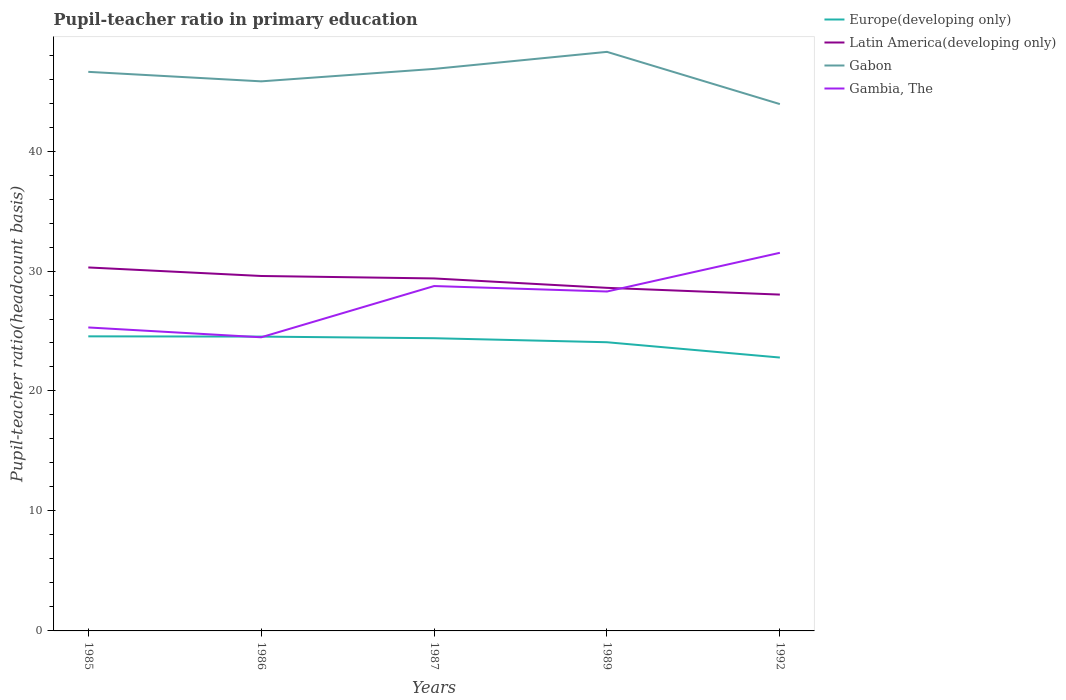Does the line corresponding to Gabon intersect with the line corresponding to Gambia, The?
Your answer should be very brief. No. Across all years, what is the maximum pupil-teacher ratio in primary education in Latin America(developing only)?
Provide a short and direct response. 28.03. In which year was the pupil-teacher ratio in primary education in Latin America(developing only) maximum?
Keep it short and to the point. 1992. What is the total pupil-teacher ratio in primary education in Europe(developing only) in the graph?
Offer a very short reply. 1.28. What is the difference between the highest and the second highest pupil-teacher ratio in primary education in Europe(developing only)?
Offer a very short reply. 1.77. What is the difference between the highest and the lowest pupil-teacher ratio in primary education in Gambia, The?
Offer a very short reply. 3. Is the pupil-teacher ratio in primary education in Gabon strictly greater than the pupil-teacher ratio in primary education in Latin America(developing only) over the years?
Ensure brevity in your answer.  No. How many lines are there?
Provide a short and direct response. 4. What is the title of the graph?
Keep it short and to the point. Pupil-teacher ratio in primary education. Does "Israel" appear as one of the legend labels in the graph?
Your answer should be compact. No. What is the label or title of the Y-axis?
Keep it short and to the point. Pupil-teacher ratio(headcount basis). What is the Pupil-teacher ratio(headcount basis) in Europe(developing only) in 1985?
Provide a short and direct response. 24.55. What is the Pupil-teacher ratio(headcount basis) in Latin America(developing only) in 1985?
Give a very brief answer. 30.3. What is the Pupil-teacher ratio(headcount basis) of Gabon in 1985?
Keep it short and to the point. 46.6. What is the Pupil-teacher ratio(headcount basis) in Gambia, The in 1985?
Make the answer very short. 25.3. What is the Pupil-teacher ratio(headcount basis) of Europe(developing only) in 1986?
Provide a succinct answer. 24.53. What is the Pupil-teacher ratio(headcount basis) of Latin America(developing only) in 1986?
Make the answer very short. 29.59. What is the Pupil-teacher ratio(headcount basis) of Gabon in 1986?
Offer a very short reply. 45.81. What is the Pupil-teacher ratio(headcount basis) of Gambia, The in 1986?
Your answer should be very brief. 24.48. What is the Pupil-teacher ratio(headcount basis) of Europe(developing only) in 1987?
Offer a very short reply. 24.4. What is the Pupil-teacher ratio(headcount basis) of Latin America(developing only) in 1987?
Offer a terse response. 29.38. What is the Pupil-teacher ratio(headcount basis) of Gabon in 1987?
Give a very brief answer. 46.85. What is the Pupil-teacher ratio(headcount basis) in Gambia, The in 1987?
Your answer should be very brief. 28.75. What is the Pupil-teacher ratio(headcount basis) of Europe(developing only) in 1989?
Offer a terse response. 24.06. What is the Pupil-teacher ratio(headcount basis) in Latin America(developing only) in 1989?
Give a very brief answer. 28.6. What is the Pupil-teacher ratio(headcount basis) of Gabon in 1989?
Offer a terse response. 48.27. What is the Pupil-teacher ratio(headcount basis) in Gambia, The in 1989?
Keep it short and to the point. 28.29. What is the Pupil-teacher ratio(headcount basis) in Europe(developing only) in 1992?
Your response must be concise. 22.79. What is the Pupil-teacher ratio(headcount basis) in Latin America(developing only) in 1992?
Offer a terse response. 28.03. What is the Pupil-teacher ratio(headcount basis) in Gabon in 1992?
Make the answer very short. 43.91. What is the Pupil-teacher ratio(headcount basis) of Gambia, The in 1992?
Give a very brief answer. 31.52. Across all years, what is the maximum Pupil-teacher ratio(headcount basis) in Europe(developing only)?
Keep it short and to the point. 24.55. Across all years, what is the maximum Pupil-teacher ratio(headcount basis) of Latin America(developing only)?
Keep it short and to the point. 30.3. Across all years, what is the maximum Pupil-teacher ratio(headcount basis) in Gabon?
Provide a short and direct response. 48.27. Across all years, what is the maximum Pupil-teacher ratio(headcount basis) of Gambia, The?
Offer a terse response. 31.52. Across all years, what is the minimum Pupil-teacher ratio(headcount basis) in Europe(developing only)?
Provide a succinct answer. 22.79. Across all years, what is the minimum Pupil-teacher ratio(headcount basis) in Latin America(developing only)?
Make the answer very short. 28.03. Across all years, what is the minimum Pupil-teacher ratio(headcount basis) in Gabon?
Give a very brief answer. 43.91. Across all years, what is the minimum Pupil-teacher ratio(headcount basis) in Gambia, The?
Your answer should be compact. 24.48. What is the total Pupil-teacher ratio(headcount basis) in Europe(developing only) in the graph?
Provide a short and direct response. 120.34. What is the total Pupil-teacher ratio(headcount basis) in Latin America(developing only) in the graph?
Your response must be concise. 145.9. What is the total Pupil-teacher ratio(headcount basis) in Gabon in the graph?
Provide a succinct answer. 231.44. What is the total Pupil-teacher ratio(headcount basis) of Gambia, The in the graph?
Your answer should be compact. 138.33. What is the difference between the Pupil-teacher ratio(headcount basis) of Europe(developing only) in 1985 and that in 1986?
Provide a short and direct response. 0.02. What is the difference between the Pupil-teacher ratio(headcount basis) of Latin America(developing only) in 1985 and that in 1986?
Give a very brief answer. 0.71. What is the difference between the Pupil-teacher ratio(headcount basis) of Gabon in 1985 and that in 1986?
Ensure brevity in your answer.  0.79. What is the difference between the Pupil-teacher ratio(headcount basis) of Gambia, The in 1985 and that in 1986?
Offer a very short reply. 0.82. What is the difference between the Pupil-teacher ratio(headcount basis) of Europe(developing only) in 1985 and that in 1987?
Your answer should be very brief. 0.16. What is the difference between the Pupil-teacher ratio(headcount basis) of Latin America(developing only) in 1985 and that in 1987?
Offer a terse response. 0.92. What is the difference between the Pupil-teacher ratio(headcount basis) in Gabon in 1985 and that in 1987?
Your answer should be compact. -0.25. What is the difference between the Pupil-teacher ratio(headcount basis) in Gambia, The in 1985 and that in 1987?
Your answer should be compact. -3.45. What is the difference between the Pupil-teacher ratio(headcount basis) in Europe(developing only) in 1985 and that in 1989?
Give a very brief answer. 0.49. What is the difference between the Pupil-teacher ratio(headcount basis) in Latin America(developing only) in 1985 and that in 1989?
Ensure brevity in your answer.  1.7. What is the difference between the Pupil-teacher ratio(headcount basis) in Gabon in 1985 and that in 1989?
Ensure brevity in your answer.  -1.67. What is the difference between the Pupil-teacher ratio(headcount basis) of Gambia, The in 1985 and that in 1989?
Give a very brief answer. -3. What is the difference between the Pupil-teacher ratio(headcount basis) of Europe(developing only) in 1985 and that in 1992?
Give a very brief answer. 1.77. What is the difference between the Pupil-teacher ratio(headcount basis) in Latin America(developing only) in 1985 and that in 1992?
Make the answer very short. 2.26. What is the difference between the Pupil-teacher ratio(headcount basis) of Gabon in 1985 and that in 1992?
Your answer should be compact. 2.69. What is the difference between the Pupil-teacher ratio(headcount basis) of Gambia, The in 1985 and that in 1992?
Your response must be concise. -6.22. What is the difference between the Pupil-teacher ratio(headcount basis) in Europe(developing only) in 1986 and that in 1987?
Make the answer very short. 0.14. What is the difference between the Pupil-teacher ratio(headcount basis) in Latin America(developing only) in 1986 and that in 1987?
Make the answer very short. 0.2. What is the difference between the Pupil-teacher ratio(headcount basis) of Gabon in 1986 and that in 1987?
Keep it short and to the point. -1.04. What is the difference between the Pupil-teacher ratio(headcount basis) of Gambia, The in 1986 and that in 1987?
Provide a short and direct response. -4.27. What is the difference between the Pupil-teacher ratio(headcount basis) of Europe(developing only) in 1986 and that in 1989?
Give a very brief answer. 0.47. What is the difference between the Pupil-teacher ratio(headcount basis) in Latin America(developing only) in 1986 and that in 1989?
Keep it short and to the point. 0.99. What is the difference between the Pupil-teacher ratio(headcount basis) in Gabon in 1986 and that in 1989?
Offer a terse response. -2.46. What is the difference between the Pupil-teacher ratio(headcount basis) of Gambia, The in 1986 and that in 1989?
Keep it short and to the point. -3.82. What is the difference between the Pupil-teacher ratio(headcount basis) of Europe(developing only) in 1986 and that in 1992?
Keep it short and to the point. 1.75. What is the difference between the Pupil-teacher ratio(headcount basis) of Latin America(developing only) in 1986 and that in 1992?
Give a very brief answer. 1.55. What is the difference between the Pupil-teacher ratio(headcount basis) of Gabon in 1986 and that in 1992?
Give a very brief answer. 1.9. What is the difference between the Pupil-teacher ratio(headcount basis) in Gambia, The in 1986 and that in 1992?
Your response must be concise. -7.04. What is the difference between the Pupil-teacher ratio(headcount basis) in Europe(developing only) in 1987 and that in 1989?
Your answer should be very brief. 0.34. What is the difference between the Pupil-teacher ratio(headcount basis) in Latin America(developing only) in 1987 and that in 1989?
Make the answer very short. 0.78. What is the difference between the Pupil-teacher ratio(headcount basis) of Gabon in 1987 and that in 1989?
Offer a very short reply. -1.42. What is the difference between the Pupil-teacher ratio(headcount basis) of Gambia, The in 1987 and that in 1989?
Ensure brevity in your answer.  0.45. What is the difference between the Pupil-teacher ratio(headcount basis) in Europe(developing only) in 1987 and that in 1992?
Ensure brevity in your answer.  1.61. What is the difference between the Pupil-teacher ratio(headcount basis) in Latin America(developing only) in 1987 and that in 1992?
Provide a succinct answer. 1.35. What is the difference between the Pupil-teacher ratio(headcount basis) in Gabon in 1987 and that in 1992?
Ensure brevity in your answer.  2.93. What is the difference between the Pupil-teacher ratio(headcount basis) in Gambia, The in 1987 and that in 1992?
Make the answer very short. -2.77. What is the difference between the Pupil-teacher ratio(headcount basis) of Europe(developing only) in 1989 and that in 1992?
Your response must be concise. 1.27. What is the difference between the Pupil-teacher ratio(headcount basis) of Latin America(developing only) in 1989 and that in 1992?
Your response must be concise. 0.56. What is the difference between the Pupil-teacher ratio(headcount basis) of Gabon in 1989 and that in 1992?
Make the answer very short. 4.35. What is the difference between the Pupil-teacher ratio(headcount basis) in Gambia, The in 1989 and that in 1992?
Your answer should be compact. -3.23. What is the difference between the Pupil-teacher ratio(headcount basis) of Europe(developing only) in 1985 and the Pupil-teacher ratio(headcount basis) of Latin America(developing only) in 1986?
Keep it short and to the point. -5.03. What is the difference between the Pupil-teacher ratio(headcount basis) of Europe(developing only) in 1985 and the Pupil-teacher ratio(headcount basis) of Gabon in 1986?
Make the answer very short. -21.26. What is the difference between the Pupil-teacher ratio(headcount basis) of Europe(developing only) in 1985 and the Pupil-teacher ratio(headcount basis) of Gambia, The in 1986?
Your answer should be compact. 0.08. What is the difference between the Pupil-teacher ratio(headcount basis) in Latin America(developing only) in 1985 and the Pupil-teacher ratio(headcount basis) in Gabon in 1986?
Your response must be concise. -15.51. What is the difference between the Pupil-teacher ratio(headcount basis) in Latin America(developing only) in 1985 and the Pupil-teacher ratio(headcount basis) in Gambia, The in 1986?
Give a very brief answer. 5.82. What is the difference between the Pupil-teacher ratio(headcount basis) of Gabon in 1985 and the Pupil-teacher ratio(headcount basis) of Gambia, The in 1986?
Offer a terse response. 22.13. What is the difference between the Pupil-teacher ratio(headcount basis) in Europe(developing only) in 1985 and the Pupil-teacher ratio(headcount basis) in Latin America(developing only) in 1987?
Keep it short and to the point. -4.83. What is the difference between the Pupil-teacher ratio(headcount basis) of Europe(developing only) in 1985 and the Pupil-teacher ratio(headcount basis) of Gabon in 1987?
Your answer should be compact. -22.29. What is the difference between the Pupil-teacher ratio(headcount basis) in Europe(developing only) in 1985 and the Pupil-teacher ratio(headcount basis) in Gambia, The in 1987?
Offer a very short reply. -4.19. What is the difference between the Pupil-teacher ratio(headcount basis) of Latin America(developing only) in 1985 and the Pupil-teacher ratio(headcount basis) of Gabon in 1987?
Give a very brief answer. -16.55. What is the difference between the Pupil-teacher ratio(headcount basis) of Latin America(developing only) in 1985 and the Pupil-teacher ratio(headcount basis) of Gambia, The in 1987?
Your response must be concise. 1.55. What is the difference between the Pupil-teacher ratio(headcount basis) in Gabon in 1985 and the Pupil-teacher ratio(headcount basis) in Gambia, The in 1987?
Ensure brevity in your answer.  17.86. What is the difference between the Pupil-teacher ratio(headcount basis) in Europe(developing only) in 1985 and the Pupil-teacher ratio(headcount basis) in Latin America(developing only) in 1989?
Ensure brevity in your answer.  -4.04. What is the difference between the Pupil-teacher ratio(headcount basis) in Europe(developing only) in 1985 and the Pupil-teacher ratio(headcount basis) in Gabon in 1989?
Ensure brevity in your answer.  -23.71. What is the difference between the Pupil-teacher ratio(headcount basis) in Europe(developing only) in 1985 and the Pupil-teacher ratio(headcount basis) in Gambia, The in 1989?
Give a very brief answer. -3.74. What is the difference between the Pupil-teacher ratio(headcount basis) in Latin America(developing only) in 1985 and the Pupil-teacher ratio(headcount basis) in Gabon in 1989?
Offer a terse response. -17.97. What is the difference between the Pupil-teacher ratio(headcount basis) of Latin America(developing only) in 1985 and the Pupil-teacher ratio(headcount basis) of Gambia, The in 1989?
Provide a short and direct response. 2.01. What is the difference between the Pupil-teacher ratio(headcount basis) of Gabon in 1985 and the Pupil-teacher ratio(headcount basis) of Gambia, The in 1989?
Offer a very short reply. 18.31. What is the difference between the Pupil-teacher ratio(headcount basis) in Europe(developing only) in 1985 and the Pupil-teacher ratio(headcount basis) in Latin America(developing only) in 1992?
Give a very brief answer. -3.48. What is the difference between the Pupil-teacher ratio(headcount basis) of Europe(developing only) in 1985 and the Pupil-teacher ratio(headcount basis) of Gabon in 1992?
Ensure brevity in your answer.  -19.36. What is the difference between the Pupil-teacher ratio(headcount basis) of Europe(developing only) in 1985 and the Pupil-teacher ratio(headcount basis) of Gambia, The in 1992?
Ensure brevity in your answer.  -6.96. What is the difference between the Pupil-teacher ratio(headcount basis) of Latin America(developing only) in 1985 and the Pupil-teacher ratio(headcount basis) of Gabon in 1992?
Give a very brief answer. -13.62. What is the difference between the Pupil-teacher ratio(headcount basis) in Latin America(developing only) in 1985 and the Pupil-teacher ratio(headcount basis) in Gambia, The in 1992?
Give a very brief answer. -1.22. What is the difference between the Pupil-teacher ratio(headcount basis) in Gabon in 1985 and the Pupil-teacher ratio(headcount basis) in Gambia, The in 1992?
Offer a very short reply. 15.08. What is the difference between the Pupil-teacher ratio(headcount basis) of Europe(developing only) in 1986 and the Pupil-teacher ratio(headcount basis) of Latin America(developing only) in 1987?
Give a very brief answer. -4.85. What is the difference between the Pupil-teacher ratio(headcount basis) of Europe(developing only) in 1986 and the Pupil-teacher ratio(headcount basis) of Gabon in 1987?
Give a very brief answer. -22.31. What is the difference between the Pupil-teacher ratio(headcount basis) of Europe(developing only) in 1986 and the Pupil-teacher ratio(headcount basis) of Gambia, The in 1987?
Provide a short and direct response. -4.21. What is the difference between the Pupil-teacher ratio(headcount basis) of Latin America(developing only) in 1986 and the Pupil-teacher ratio(headcount basis) of Gabon in 1987?
Offer a terse response. -17.26. What is the difference between the Pupil-teacher ratio(headcount basis) in Latin America(developing only) in 1986 and the Pupil-teacher ratio(headcount basis) in Gambia, The in 1987?
Your answer should be very brief. 0.84. What is the difference between the Pupil-teacher ratio(headcount basis) in Gabon in 1986 and the Pupil-teacher ratio(headcount basis) in Gambia, The in 1987?
Ensure brevity in your answer.  17.06. What is the difference between the Pupil-teacher ratio(headcount basis) of Europe(developing only) in 1986 and the Pupil-teacher ratio(headcount basis) of Latin America(developing only) in 1989?
Your response must be concise. -4.06. What is the difference between the Pupil-teacher ratio(headcount basis) of Europe(developing only) in 1986 and the Pupil-teacher ratio(headcount basis) of Gabon in 1989?
Offer a very short reply. -23.73. What is the difference between the Pupil-teacher ratio(headcount basis) of Europe(developing only) in 1986 and the Pupil-teacher ratio(headcount basis) of Gambia, The in 1989?
Provide a succinct answer. -3.76. What is the difference between the Pupil-teacher ratio(headcount basis) of Latin America(developing only) in 1986 and the Pupil-teacher ratio(headcount basis) of Gabon in 1989?
Offer a very short reply. -18.68. What is the difference between the Pupil-teacher ratio(headcount basis) of Latin America(developing only) in 1986 and the Pupil-teacher ratio(headcount basis) of Gambia, The in 1989?
Make the answer very short. 1.29. What is the difference between the Pupil-teacher ratio(headcount basis) of Gabon in 1986 and the Pupil-teacher ratio(headcount basis) of Gambia, The in 1989?
Provide a succinct answer. 17.52. What is the difference between the Pupil-teacher ratio(headcount basis) of Europe(developing only) in 1986 and the Pupil-teacher ratio(headcount basis) of Latin America(developing only) in 1992?
Offer a terse response. -3.5. What is the difference between the Pupil-teacher ratio(headcount basis) in Europe(developing only) in 1986 and the Pupil-teacher ratio(headcount basis) in Gabon in 1992?
Offer a very short reply. -19.38. What is the difference between the Pupil-teacher ratio(headcount basis) in Europe(developing only) in 1986 and the Pupil-teacher ratio(headcount basis) in Gambia, The in 1992?
Ensure brevity in your answer.  -6.98. What is the difference between the Pupil-teacher ratio(headcount basis) of Latin America(developing only) in 1986 and the Pupil-teacher ratio(headcount basis) of Gabon in 1992?
Provide a succinct answer. -14.33. What is the difference between the Pupil-teacher ratio(headcount basis) in Latin America(developing only) in 1986 and the Pupil-teacher ratio(headcount basis) in Gambia, The in 1992?
Make the answer very short. -1.93. What is the difference between the Pupil-teacher ratio(headcount basis) of Gabon in 1986 and the Pupil-teacher ratio(headcount basis) of Gambia, The in 1992?
Provide a short and direct response. 14.29. What is the difference between the Pupil-teacher ratio(headcount basis) in Europe(developing only) in 1987 and the Pupil-teacher ratio(headcount basis) in Latin America(developing only) in 1989?
Keep it short and to the point. -4.2. What is the difference between the Pupil-teacher ratio(headcount basis) of Europe(developing only) in 1987 and the Pupil-teacher ratio(headcount basis) of Gabon in 1989?
Provide a succinct answer. -23.87. What is the difference between the Pupil-teacher ratio(headcount basis) in Europe(developing only) in 1987 and the Pupil-teacher ratio(headcount basis) in Gambia, The in 1989?
Your answer should be very brief. -3.89. What is the difference between the Pupil-teacher ratio(headcount basis) in Latin America(developing only) in 1987 and the Pupil-teacher ratio(headcount basis) in Gabon in 1989?
Your response must be concise. -18.89. What is the difference between the Pupil-teacher ratio(headcount basis) in Latin America(developing only) in 1987 and the Pupil-teacher ratio(headcount basis) in Gambia, The in 1989?
Provide a short and direct response. 1.09. What is the difference between the Pupil-teacher ratio(headcount basis) in Gabon in 1987 and the Pupil-teacher ratio(headcount basis) in Gambia, The in 1989?
Ensure brevity in your answer.  18.56. What is the difference between the Pupil-teacher ratio(headcount basis) in Europe(developing only) in 1987 and the Pupil-teacher ratio(headcount basis) in Latin America(developing only) in 1992?
Your answer should be compact. -3.64. What is the difference between the Pupil-teacher ratio(headcount basis) of Europe(developing only) in 1987 and the Pupil-teacher ratio(headcount basis) of Gabon in 1992?
Provide a succinct answer. -19.52. What is the difference between the Pupil-teacher ratio(headcount basis) of Europe(developing only) in 1987 and the Pupil-teacher ratio(headcount basis) of Gambia, The in 1992?
Offer a very short reply. -7.12. What is the difference between the Pupil-teacher ratio(headcount basis) of Latin America(developing only) in 1987 and the Pupil-teacher ratio(headcount basis) of Gabon in 1992?
Your response must be concise. -14.53. What is the difference between the Pupil-teacher ratio(headcount basis) in Latin America(developing only) in 1987 and the Pupil-teacher ratio(headcount basis) in Gambia, The in 1992?
Ensure brevity in your answer.  -2.14. What is the difference between the Pupil-teacher ratio(headcount basis) of Gabon in 1987 and the Pupil-teacher ratio(headcount basis) of Gambia, The in 1992?
Give a very brief answer. 15.33. What is the difference between the Pupil-teacher ratio(headcount basis) of Europe(developing only) in 1989 and the Pupil-teacher ratio(headcount basis) of Latin America(developing only) in 1992?
Your answer should be very brief. -3.97. What is the difference between the Pupil-teacher ratio(headcount basis) in Europe(developing only) in 1989 and the Pupil-teacher ratio(headcount basis) in Gabon in 1992?
Give a very brief answer. -19.85. What is the difference between the Pupil-teacher ratio(headcount basis) of Europe(developing only) in 1989 and the Pupil-teacher ratio(headcount basis) of Gambia, The in 1992?
Offer a terse response. -7.45. What is the difference between the Pupil-teacher ratio(headcount basis) in Latin America(developing only) in 1989 and the Pupil-teacher ratio(headcount basis) in Gabon in 1992?
Provide a short and direct response. -15.32. What is the difference between the Pupil-teacher ratio(headcount basis) in Latin America(developing only) in 1989 and the Pupil-teacher ratio(headcount basis) in Gambia, The in 1992?
Make the answer very short. -2.92. What is the difference between the Pupil-teacher ratio(headcount basis) of Gabon in 1989 and the Pupil-teacher ratio(headcount basis) of Gambia, The in 1992?
Offer a very short reply. 16.75. What is the average Pupil-teacher ratio(headcount basis) of Europe(developing only) per year?
Make the answer very short. 24.07. What is the average Pupil-teacher ratio(headcount basis) in Latin America(developing only) per year?
Give a very brief answer. 29.18. What is the average Pupil-teacher ratio(headcount basis) in Gabon per year?
Ensure brevity in your answer.  46.29. What is the average Pupil-teacher ratio(headcount basis) of Gambia, The per year?
Your answer should be compact. 27.67. In the year 1985, what is the difference between the Pupil-teacher ratio(headcount basis) in Europe(developing only) and Pupil-teacher ratio(headcount basis) in Latin America(developing only)?
Your response must be concise. -5.74. In the year 1985, what is the difference between the Pupil-teacher ratio(headcount basis) of Europe(developing only) and Pupil-teacher ratio(headcount basis) of Gabon?
Your response must be concise. -22.05. In the year 1985, what is the difference between the Pupil-teacher ratio(headcount basis) in Europe(developing only) and Pupil-teacher ratio(headcount basis) in Gambia, The?
Your answer should be compact. -0.74. In the year 1985, what is the difference between the Pupil-teacher ratio(headcount basis) of Latin America(developing only) and Pupil-teacher ratio(headcount basis) of Gabon?
Your answer should be very brief. -16.3. In the year 1985, what is the difference between the Pupil-teacher ratio(headcount basis) of Latin America(developing only) and Pupil-teacher ratio(headcount basis) of Gambia, The?
Your answer should be compact. 5. In the year 1985, what is the difference between the Pupil-teacher ratio(headcount basis) in Gabon and Pupil-teacher ratio(headcount basis) in Gambia, The?
Provide a short and direct response. 21.31. In the year 1986, what is the difference between the Pupil-teacher ratio(headcount basis) of Europe(developing only) and Pupil-teacher ratio(headcount basis) of Latin America(developing only)?
Offer a very short reply. -5.05. In the year 1986, what is the difference between the Pupil-teacher ratio(headcount basis) in Europe(developing only) and Pupil-teacher ratio(headcount basis) in Gabon?
Offer a terse response. -21.28. In the year 1986, what is the difference between the Pupil-teacher ratio(headcount basis) of Europe(developing only) and Pupil-teacher ratio(headcount basis) of Gambia, The?
Provide a succinct answer. 0.06. In the year 1986, what is the difference between the Pupil-teacher ratio(headcount basis) of Latin America(developing only) and Pupil-teacher ratio(headcount basis) of Gabon?
Make the answer very short. -16.22. In the year 1986, what is the difference between the Pupil-teacher ratio(headcount basis) of Latin America(developing only) and Pupil-teacher ratio(headcount basis) of Gambia, The?
Your answer should be very brief. 5.11. In the year 1986, what is the difference between the Pupil-teacher ratio(headcount basis) in Gabon and Pupil-teacher ratio(headcount basis) in Gambia, The?
Provide a short and direct response. 21.33. In the year 1987, what is the difference between the Pupil-teacher ratio(headcount basis) in Europe(developing only) and Pupil-teacher ratio(headcount basis) in Latin America(developing only)?
Your response must be concise. -4.98. In the year 1987, what is the difference between the Pupil-teacher ratio(headcount basis) in Europe(developing only) and Pupil-teacher ratio(headcount basis) in Gabon?
Your answer should be very brief. -22.45. In the year 1987, what is the difference between the Pupil-teacher ratio(headcount basis) in Europe(developing only) and Pupil-teacher ratio(headcount basis) in Gambia, The?
Make the answer very short. -4.35. In the year 1987, what is the difference between the Pupil-teacher ratio(headcount basis) of Latin America(developing only) and Pupil-teacher ratio(headcount basis) of Gabon?
Make the answer very short. -17.47. In the year 1987, what is the difference between the Pupil-teacher ratio(headcount basis) in Latin America(developing only) and Pupil-teacher ratio(headcount basis) in Gambia, The?
Offer a terse response. 0.63. In the year 1987, what is the difference between the Pupil-teacher ratio(headcount basis) of Gabon and Pupil-teacher ratio(headcount basis) of Gambia, The?
Provide a succinct answer. 18.1. In the year 1989, what is the difference between the Pupil-teacher ratio(headcount basis) in Europe(developing only) and Pupil-teacher ratio(headcount basis) in Latin America(developing only)?
Keep it short and to the point. -4.53. In the year 1989, what is the difference between the Pupil-teacher ratio(headcount basis) in Europe(developing only) and Pupil-teacher ratio(headcount basis) in Gabon?
Offer a very short reply. -24.21. In the year 1989, what is the difference between the Pupil-teacher ratio(headcount basis) in Europe(developing only) and Pupil-teacher ratio(headcount basis) in Gambia, The?
Offer a very short reply. -4.23. In the year 1989, what is the difference between the Pupil-teacher ratio(headcount basis) of Latin America(developing only) and Pupil-teacher ratio(headcount basis) of Gabon?
Your answer should be compact. -19.67. In the year 1989, what is the difference between the Pupil-teacher ratio(headcount basis) of Latin America(developing only) and Pupil-teacher ratio(headcount basis) of Gambia, The?
Your response must be concise. 0.3. In the year 1989, what is the difference between the Pupil-teacher ratio(headcount basis) in Gabon and Pupil-teacher ratio(headcount basis) in Gambia, The?
Make the answer very short. 19.98. In the year 1992, what is the difference between the Pupil-teacher ratio(headcount basis) in Europe(developing only) and Pupil-teacher ratio(headcount basis) in Latin America(developing only)?
Your response must be concise. -5.25. In the year 1992, what is the difference between the Pupil-teacher ratio(headcount basis) of Europe(developing only) and Pupil-teacher ratio(headcount basis) of Gabon?
Make the answer very short. -21.13. In the year 1992, what is the difference between the Pupil-teacher ratio(headcount basis) of Europe(developing only) and Pupil-teacher ratio(headcount basis) of Gambia, The?
Offer a very short reply. -8.73. In the year 1992, what is the difference between the Pupil-teacher ratio(headcount basis) of Latin America(developing only) and Pupil-teacher ratio(headcount basis) of Gabon?
Provide a succinct answer. -15.88. In the year 1992, what is the difference between the Pupil-teacher ratio(headcount basis) in Latin America(developing only) and Pupil-teacher ratio(headcount basis) in Gambia, The?
Provide a succinct answer. -3.48. In the year 1992, what is the difference between the Pupil-teacher ratio(headcount basis) of Gabon and Pupil-teacher ratio(headcount basis) of Gambia, The?
Your answer should be very brief. 12.4. What is the ratio of the Pupil-teacher ratio(headcount basis) in Latin America(developing only) in 1985 to that in 1986?
Keep it short and to the point. 1.02. What is the ratio of the Pupil-teacher ratio(headcount basis) of Gabon in 1985 to that in 1986?
Provide a succinct answer. 1.02. What is the ratio of the Pupil-teacher ratio(headcount basis) in Gambia, The in 1985 to that in 1986?
Your response must be concise. 1.03. What is the ratio of the Pupil-teacher ratio(headcount basis) in Europe(developing only) in 1985 to that in 1987?
Offer a terse response. 1.01. What is the ratio of the Pupil-teacher ratio(headcount basis) in Latin America(developing only) in 1985 to that in 1987?
Provide a short and direct response. 1.03. What is the ratio of the Pupil-teacher ratio(headcount basis) of Gambia, The in 1985 to that in 1987?
Your response must be concise. 0.88. What is the ratio of the Pupil-teacher ratio(headcount basis) of Europe(developing only) in 1985 to that in 1989?
Your response must be concise. 1.02. What is the ratio of the Pupil-teacher ratio(headcount basis) in Latin America(developing only) in 1985 to that in 1989?
Provide a succinct answer. 1.06. What is the ratio of the Pupil-teacher ratio(headcount basis) in Gabon in 1985 to that in 1989?
Give a very brief answer. 0.97. What is the ratio of the Pupil-teacher ratio(headcount basis) in Gambia, The in 1985 to that in 1989?
Your answer should be very brief. 0.89. What is the ratio of the Pupil-teacher ratio(headcount basis) of Europe(developing only) in 1985 to that in 1992?
Ensure brevity in your answer.  1.08. What is the ratio of the Pupil-teacher ratio(headcount basis) of Latin America(developing only) in 1985 to that in 1992?
Keep it short and to the point. 1.08. What is the ratio of the Pupil-teacher ratio(headcount basis) of Gabon in 1985 to that in 1992?
Make the answer very short. 1.06. What is the ratio of the Pupil-teacher ratio(headcount basis) of Gambia, The in 1985 to that in 1992?
Keep it short and to the point. 0.8. What is the ratio of the Pupil-teacher ratio(headcount basis) of Europe(developing only) in 1986 to that in 1987?
Keep it short and to the point. 1.01. What is the ratio of the Pupil-teacher ratio(headcount basis) in Gabon in 1986 to that in 1987?
Provide a succinct answer. 0.98. What is the ratio of the Pupil-teacher ratio(headcount basis) of Gambia, The in 1986 to that in 1987?
Give a very brief answer. 0.85. What is the ratio of the Pupil-teacher ratio(headcount basis) in Europe(developing only) in 1986 to that in 1989?
Provide a short and direct response. 1.02. What is the ratio of the Pupil-teacher ratio(headcount basis) of Latin America(developing only) in 1986 to that in 1989?
Make the answer very short. 1.03. What is the ratio of the Pupil-teacher ratio(headcount basis) of Gabon in 1986 to that in 1989?
Provide a succinct answer. 0.95. What is the ratio of the Pupil-teacher ratio(headcount basis) of Gambia, The in 1986 to that in 1989?
Provide a short and direct response. 0.87. What is the ratio of the Pupil-teacher ratio(headcount basis) in Europe(developing only) in 1986 to that in 1992?
Your answer should be very brief. 1.08. What is the ratio of the Pupil-teacher ratio(headcount basis) of Latin America(developing only) in 1986 to that in 1992?
Your answer should be compact. 1.06. What is the ratio of the Pupil-teacher ratio(headcount basis) of Gabon in 1986 to that in 1992?
Your answer should be very brief. 1.04. What is the ratio of the Pupil-teacher ratio(headcount basis) of Gambia, The in 1986 to that in 1992?
Your response must be concise. 0.78. What is the ratio of the Pupil-teacher ratio(headcount basis) in Europe(developing only) in 1987 to that in 1989?
Ensure brevity in your answer.  1.01. What is the ratio of the Pupil-teacher ratio(headcount basis) of Latin America(developing only) in 1987 to that in 1989?
Offer a terse response. 1.03. What is the ratio of the Pupil-teacher ratio(headcount basis) in Gabon in 1987 to that in 1989?
Offer a very short reply. 0.97. What is the ratio of the Pupil-teacher ratio(headcount basis) in Gambia, The in 1987 to that in 1989?
Provide a succinct answer. 1.02. What is the ratio of the Pupil-teacher ratio(headcount basis) of Europe(developing only) in 1987 to that in 1992?
Provide a short and direct response. 1.07. What is the ratio of the Pupil-teacher ratio(headcount basis) in Latin America(developing only) in 1987 to that in 1992?
Make the answer very short. 1.05. What is the ratio of the Pupil-teacher ratio(headcount basis) in Gabon in 1987 to that in 1992?
Your answer should be very brief. 1.07. What is the ratio of the Pupil-teacher ratio(headcount basis) in Gambia, The in 1987 to that in 1992?
Offer a very short reply. 0.91. What is the ratio of the Pupil-teacher ratio(headcount basis) in Europe(developing only) in 1989 to that in 1992?
Your response must be concise. 1.06. What is the ratio of the Pupil-teacher ratio(headcount basis) in Latin America(developing only) in 1989 to that in 1992?
Offer a very short reply. 1.02. What is the ratio of the Pupil-teacher ratio(headcount basis) of Gabon in 1989 to that in 1992?
Keep it short and to the point. 1.1. What is the ratio of the Pupil-teacher ratio(headcount basis) of Gambia, The in 1989 to that in 1992?
Make the answer very short. 0.9. What is the difference between the highest and the second highest Pupil-teacher ratio(headcount basis) of Europe(developing only)?
Offer a terse response. 0.02. What is the difference between the highest and the second highest Pupil-teacher ratio(headcount basis) in Latin America(developing only)?
Give a very brief answer. 0.71. What is the difference between the highest and the second highest Pupil-teacher ratio(headcount basis) of Gabon?
Provide a short and direct response. 1.42. What is the difference between the highest and the second highest Pupil-teacher ratio(headcount basis) in Gambia, The?
Keep it short and to the point. 2.77. What is the difference between the highest and the lowest Pupil-teacher ratio(headcount basis) in Europe(developing only)?
Give a very brief answer. 1.77. What is the difference between the highest and the lowest Pupil-teacher ratio(headcount basis) in Latin America(developing only)?
Keep it short and to the point. 2.26. What is the difference between the highest and the lowest Pupil-teacher ratio(headcount basis) in Gabon?
Make the answer very short. 4.35. What is the difference between the highest and the lowest Pupil-teacher ratio(headcount basis) in Gambia, The?
Your response must be concise. 7.04. 